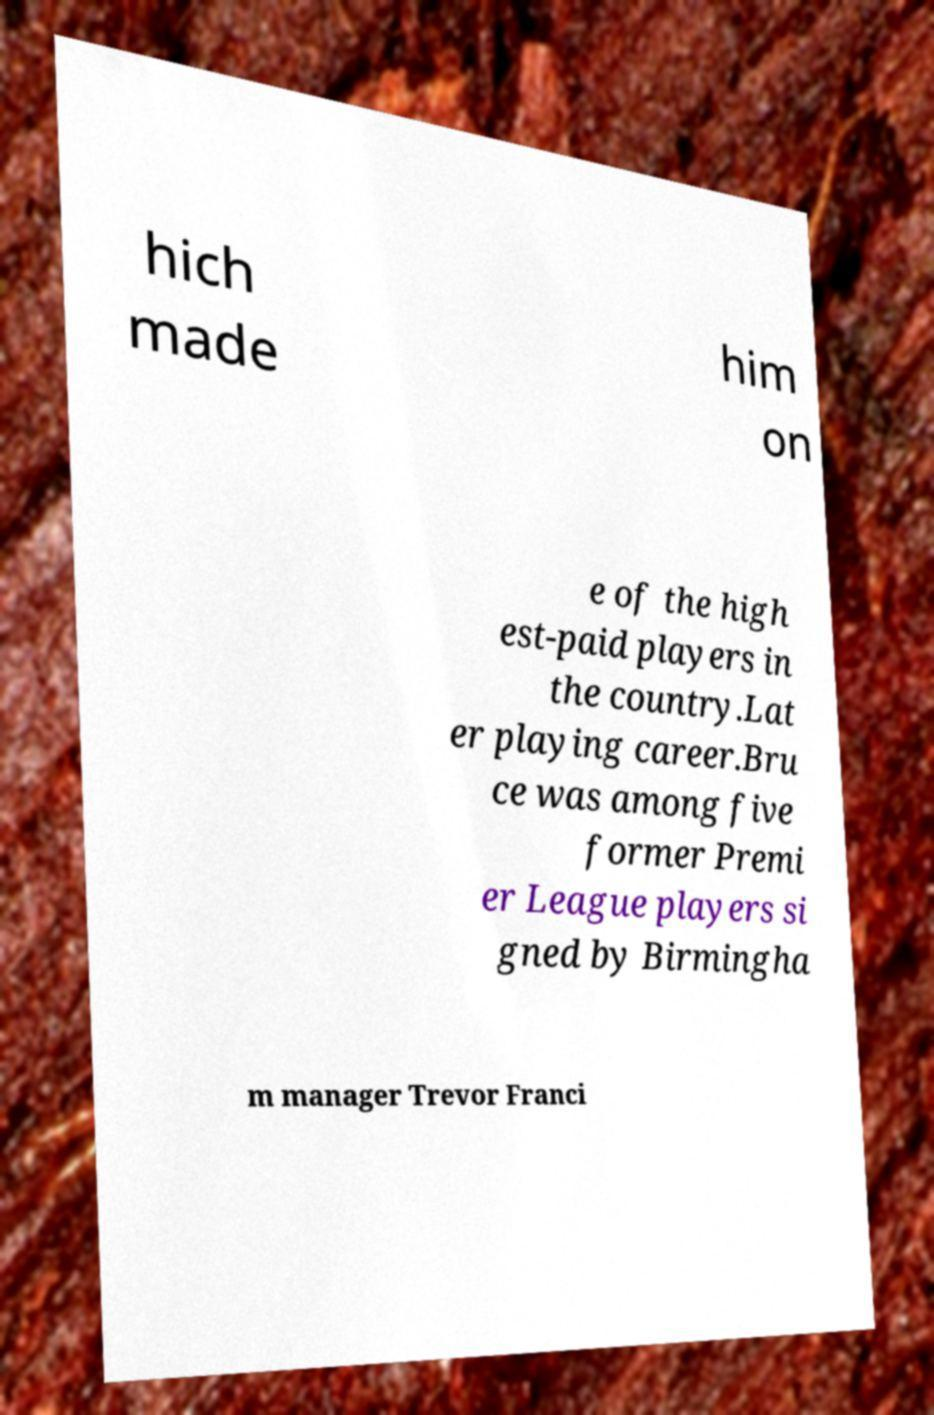I need the written content from this picture converted into text. Can you do that? hich made him on e of the high est-paid players in the country.Lat er playing career.Bru ce was among five former Premi er League players si gned by Birmingha m manager Trevor Franci 